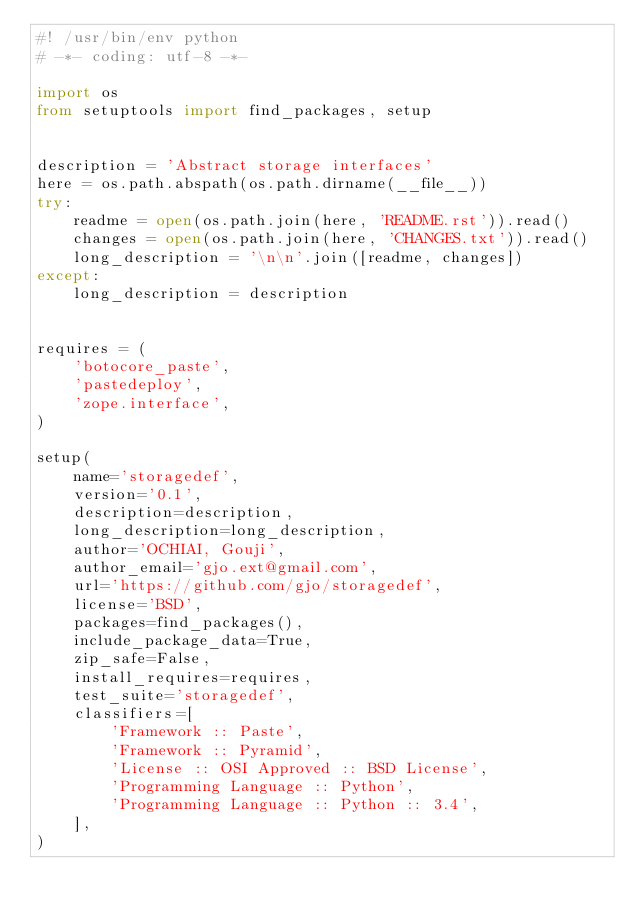<code> <loc_0><loc_0><loc_500><loc_500><_Python_>#! /usr/bin/env python
# -*- coding: utf-8 -*-

import os
from setuptools import find_packages, setup


description = 'Abstract storage interfaces'
here = os.path.abspath(os.path.dirname(__file__))
try:
    readme = open(os.path.join(here, 'README.rst')).read()
    changes = open(os.path.join(here, 'CHANGES.txt')).read()
    long_description = '\n\n'.join([readme, changes])
except:
    long_description = description


requires = (
    'botocore_paste',
    'pastedeploy',
    'zope.interface',
)

setup(
    name='storagedef',
    version='0.1',
    description=description,
    long_description=long_description,
    author='OCHIAI, Gouji',
    author_email='gjo.ext@gmail.com',
    url='https://github.com/gjo/storagedef',
    license='BSD',
    packages=find_packages(),
    include_package_data=True,
    zip_safe=False,
    install_requires=requires,
    test_suite='storagedef',
    classifiers=[
        'Framework :: Paste',
        'Framework :: Pyramid',
        'License :: OSI Approved :: BSD License',
        'Programming Language :: Python',
        'Programming Language :: Python :: 3.4',
    ],
)
</code> 